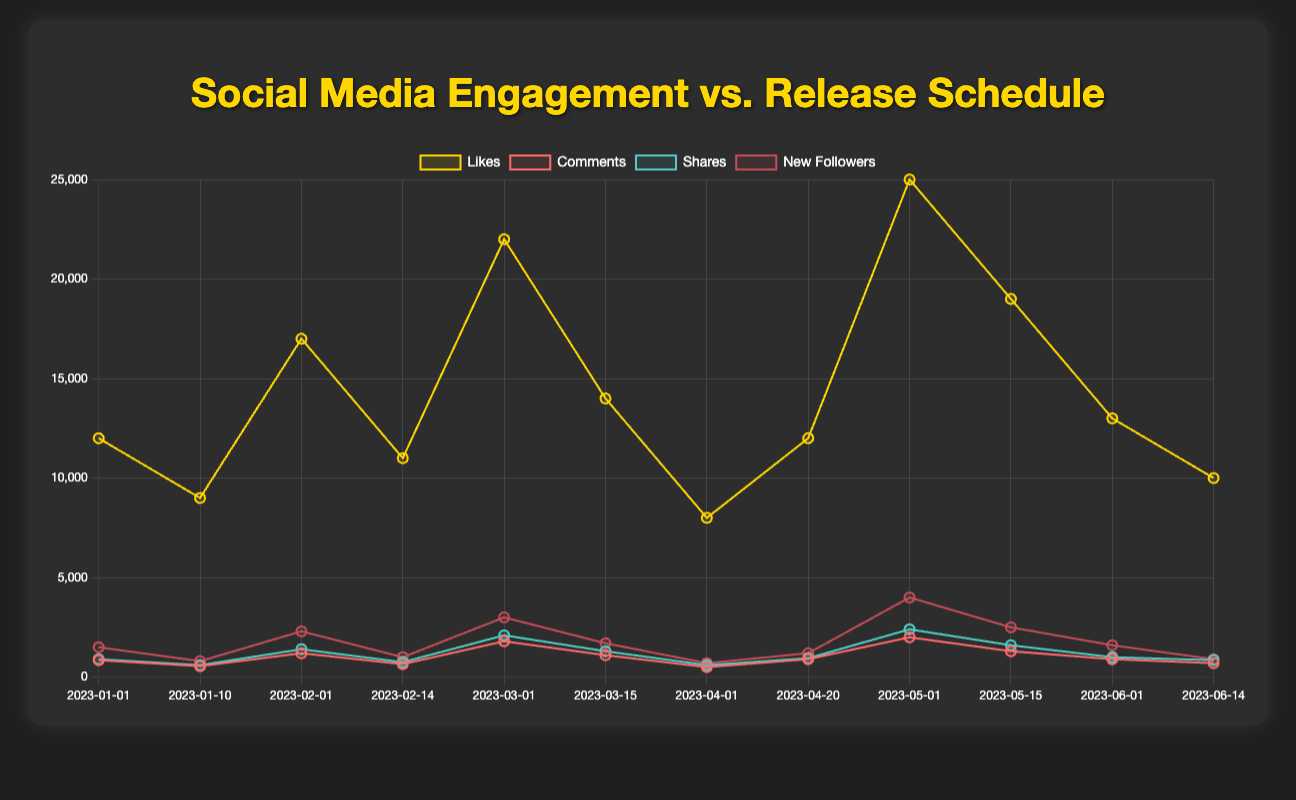Which music release event had the highest likes on social media? Based on the figure, the music release event with the highest likes is observed. The top likes value is 25000, which is associated with the "Challenge Announcement" on TikTok.
Answer: Challenge Announcement on TikTok On which date did YouTube see the highest engagement in terms of new followers? Look for the data points corresponding to YouTube and compare their new followers values. The highest value of 3000 occurs on March 1, 2023, during the "Music Video Release".
Answer: March 1, 2023 What is the difference in likes between the "Single Release" on January 1, 2023, and June 1, 2023, on Instagram? Check the likes for both events. On January 1, the likes were 12000, and on June 1, the likes were 13000. The difference is calculated as 13000 - 12000.
Answer: 1000 Which music release event led to the greatest number of comments on Twitter? Identify the data points related to Twitter. The comments for "Album Release" are 1200 and for "Promotion" are 650. The highest comments value, 1200, corresponds to the "Album Release".
Answer: Album Release Which social media platform had the highest shares during the given timeframe? Compare the shares values across all platforms. The highest value of 2400 is seen on TikTok during the "Challenge Announcement".
Answer: TikTok What is the average number of new followers gained from Instagram posts related to "Single Release"? Add the "new followers" values for Instagram's "Single Release" events on January 1 (1500) and June 1 (1600). Divide by 2: (1500 + 1600) / 2.
Answer: 1550 Compare the likes of "Music Video Release" on YouTube to the likes of "Challenge Announcement" on TikTok. Which one had higher engagement? Check the likes for both events: 22000 for "Music Video Release" on YouTube and 25000 for "Challenge Announcement" on TikTok. TikTok's event had higher likes.
Answer: Challenge Announcement on TikTok What is the combined number of shares for all music events on Facebook? Summing the shares for Facebook events: 600 (Single Release) + 950 (Live Stream), the total is 600 + 950.
Answer: 1550 